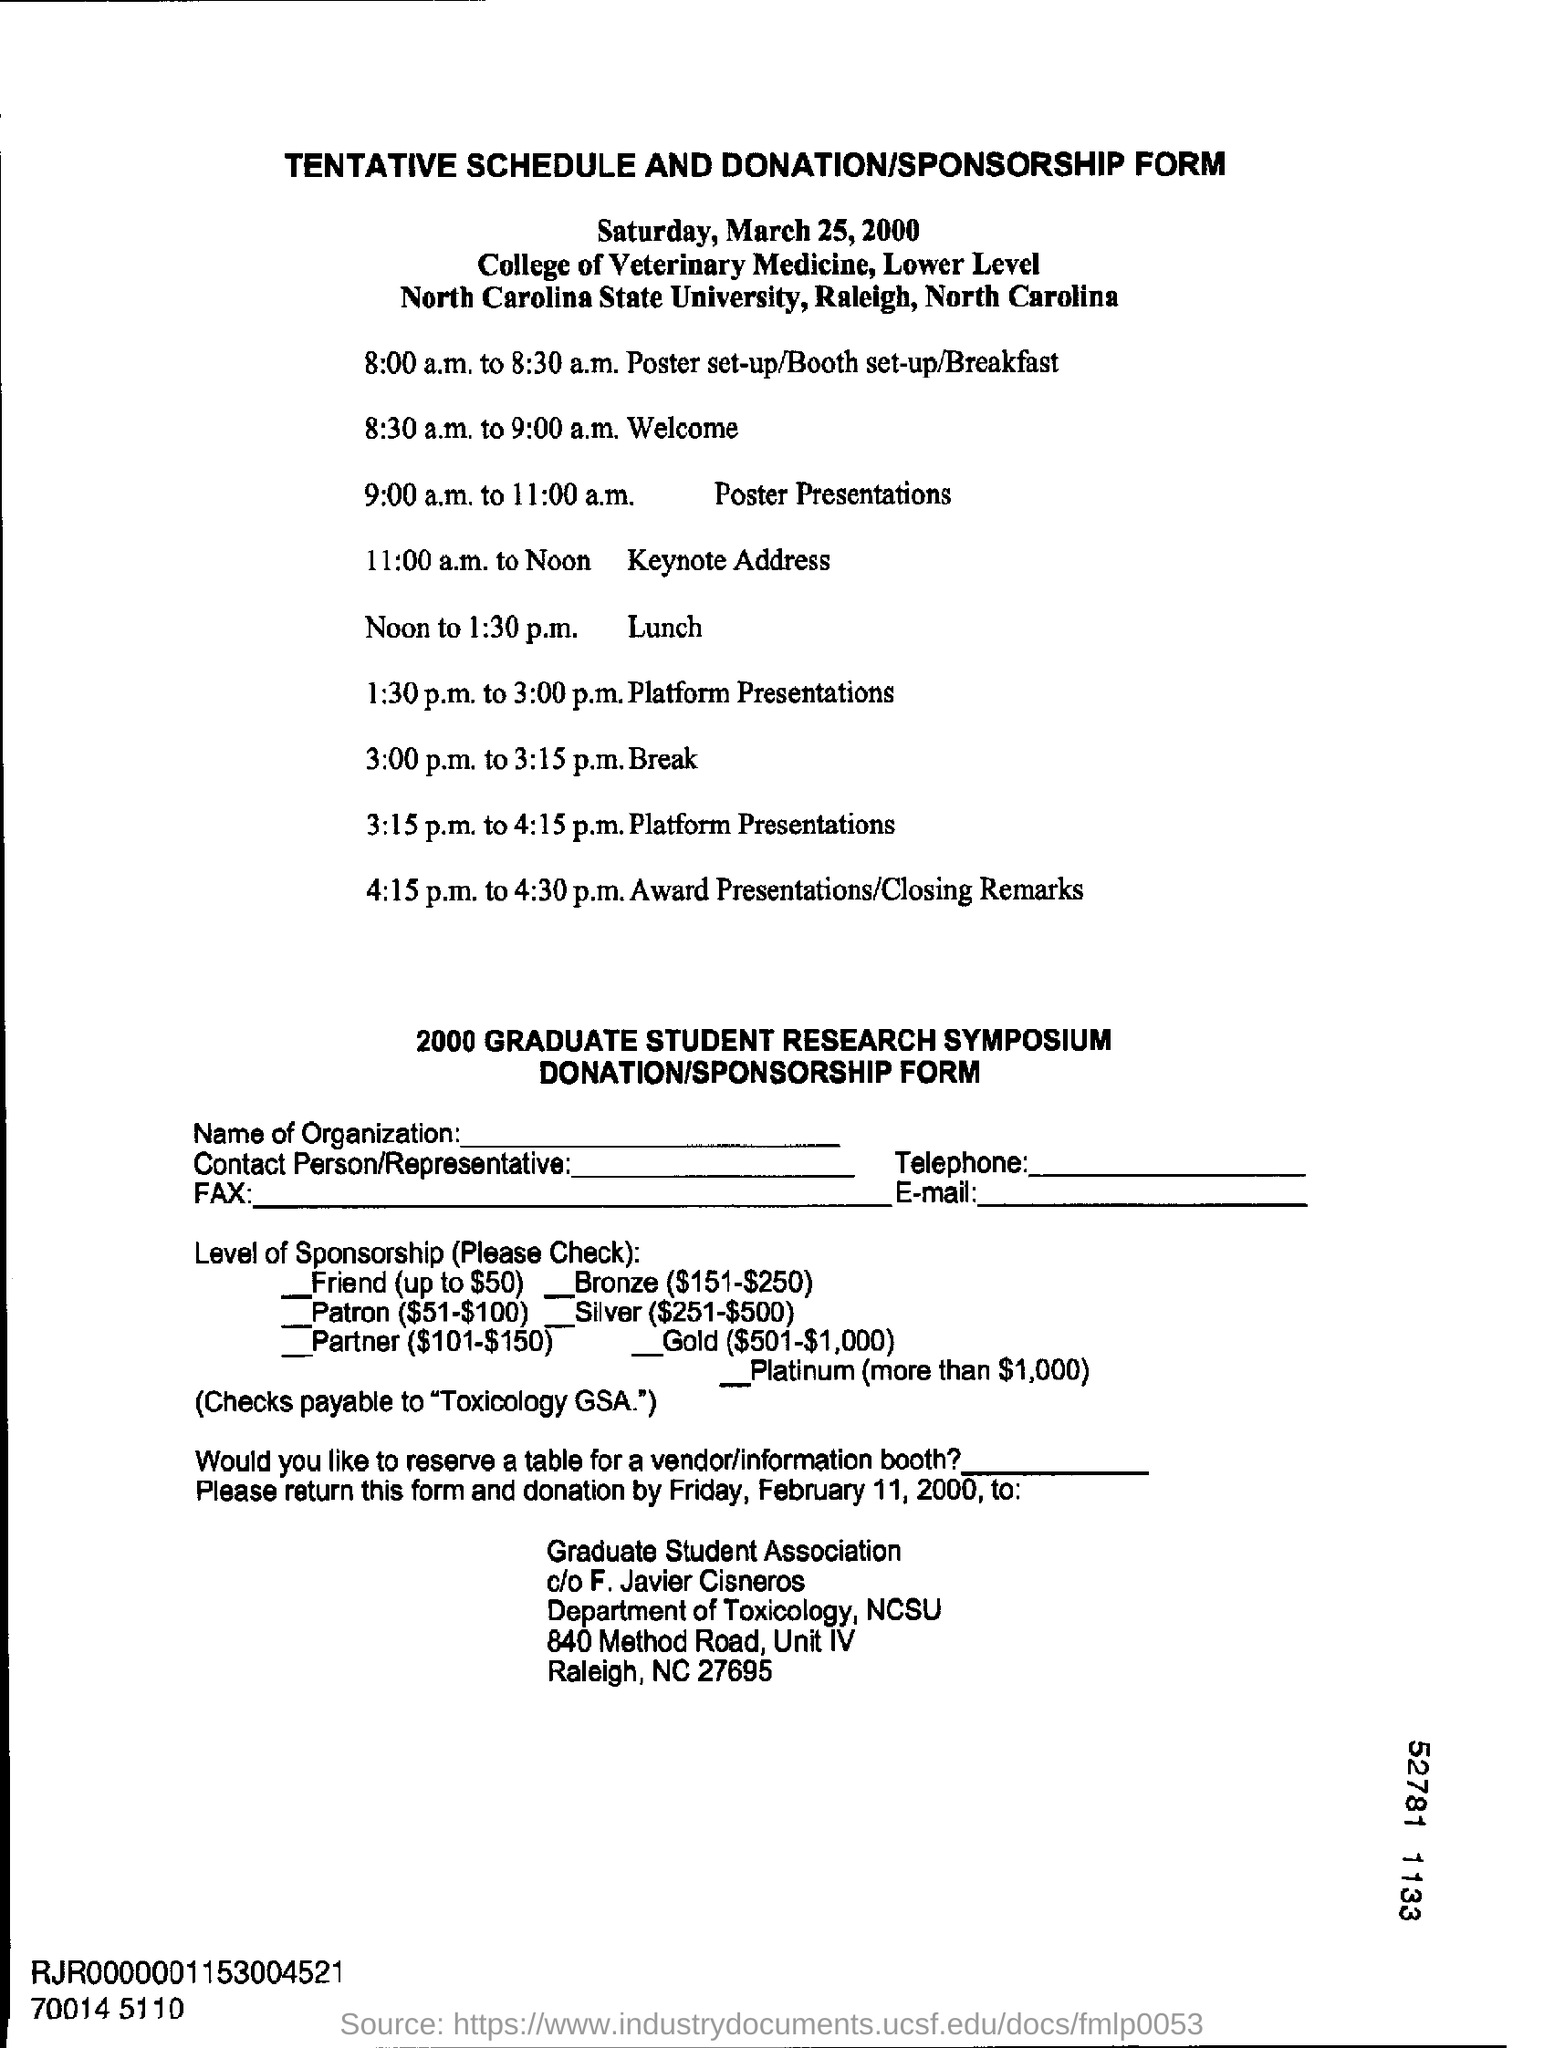What is the date mentioned in the top of the document?
Make the answer very short. Saturday, March 25, 2000. What is the Lunch Time ?
Provide a short and direct response. Noon to 1:30 p.m. What is the Break Timing ?
Ensure brevity in your answer.  3:00 p.m. to 3:15 p.m. 